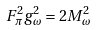Convert formula to latex. <formula><loc_0><loc_0><loc_500><loc_500>F _ { \pi } ^ { 2 } g _ { \omega } ^ { 2 } = 2 M _ { \omega } ^ { 2 }</formula> 